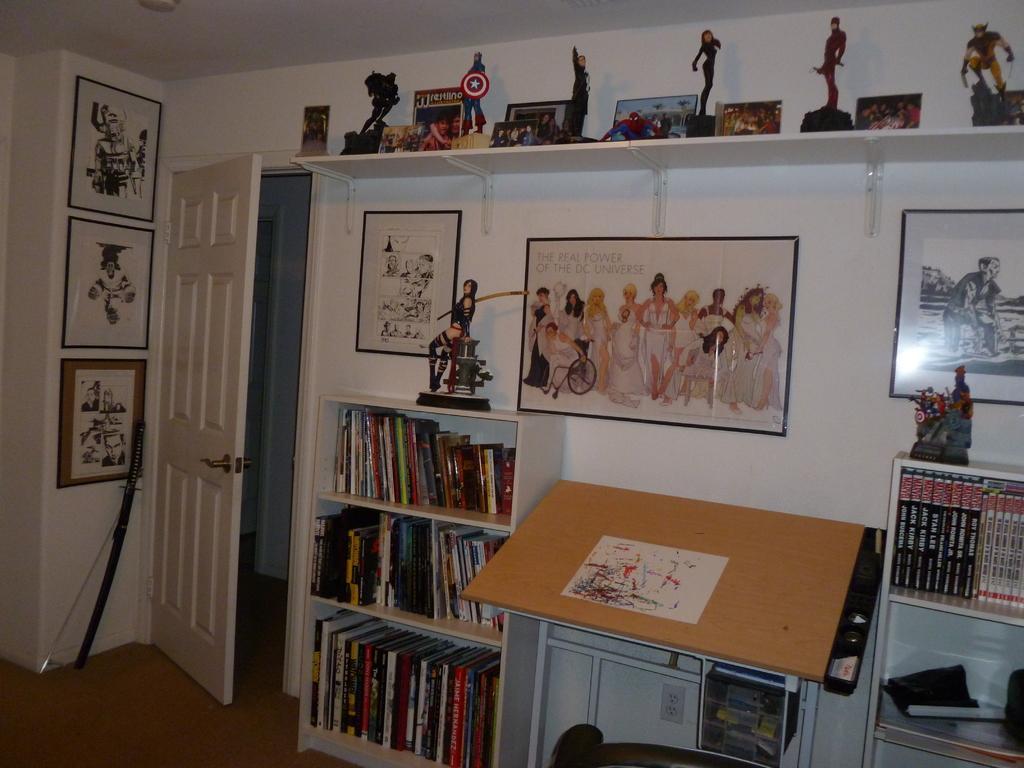Please provide a concise description of this image. In this picture I can see there is a sword placed here at left side, there are few photo frames arranged on the wall, there is a door and on to right there is a table, there are few books arranged in the book shelves and there are few more photo frames and statues placed on the wooden shelf, it is at the top of the image. 